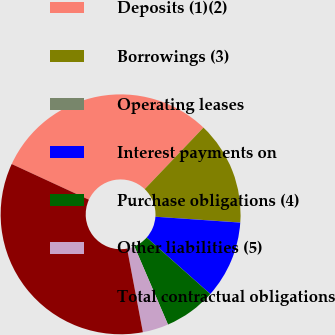<chart> <loc_0><loc_0><loc_500><loc_500><pie_chart><fcel>Deposits (1)(2)<fcel>Borrowings (3)<fcel>Operating leases<fcel>Interest payments on<fcel>Purchase obligations (4)<fcel>Other liabilities (5)<fcel>Total contractual obligations<nl><fcel>30.25%<fcel>13.95%<fcel>0.01%<fcel>10.46%<fcel>6.98%<fcel>3.49%<fcel>34.86%<nl></chart> 